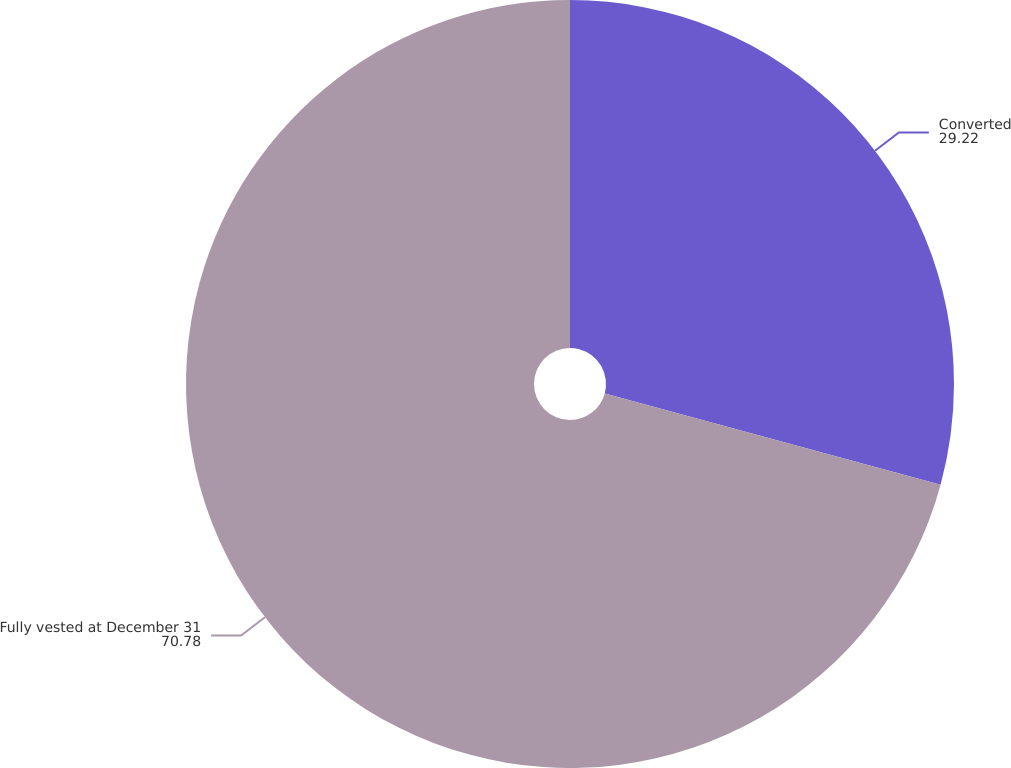Convert chart to OTSL. <chart><loc_0><loc_0><loc_500><loc_500><pie_chart><fcel>Converted<fcel>Fully vested at December 31<nl><fcel>29.22%<fcel>70.78%<nl></chart> 